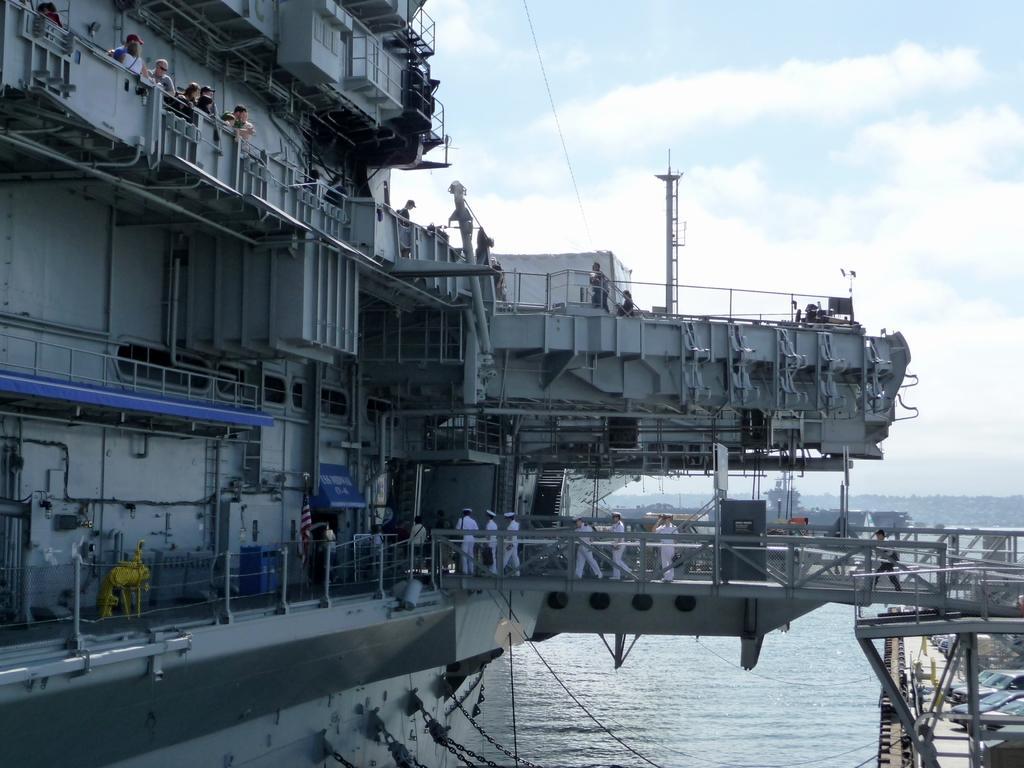In one or two sentences, can you explain what this image depicts? In this picture I can see the cargo ship on the water. On the left I can see some people who are standing near to the fencing. In the center I can see the officers who are wearing white dress and crossing the bridge. In the background I can see the mountain and trees. At the top I can see the sky and clouds. 